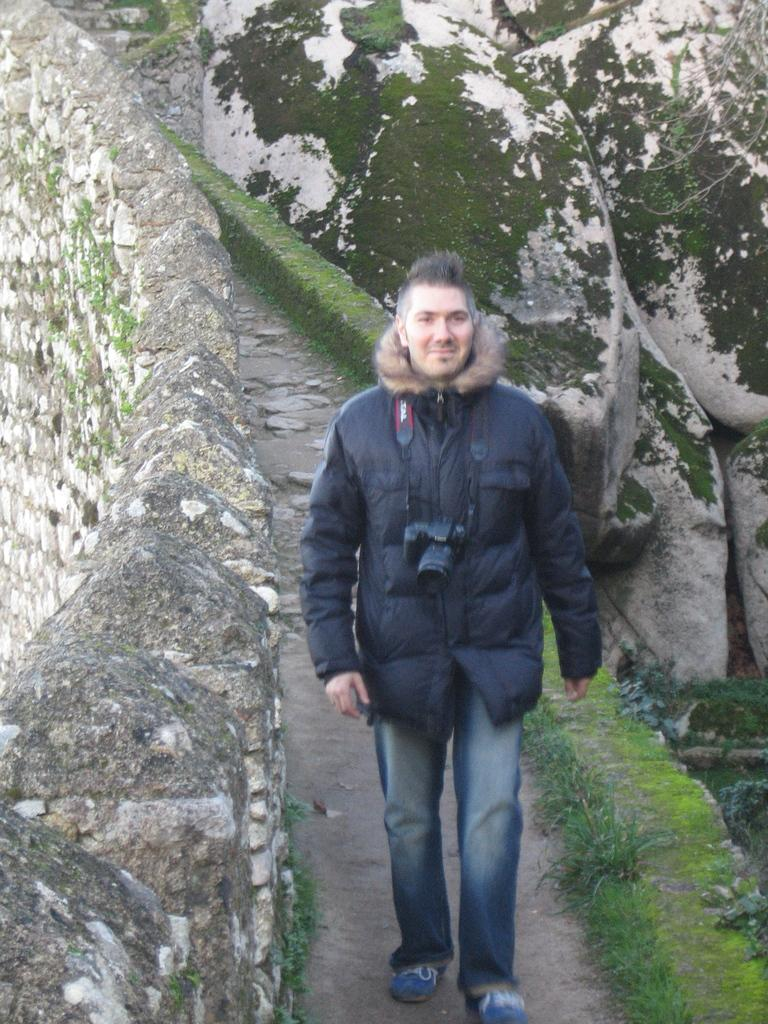Who or what is in the image? There is a person in the image. What type of natural environment is visible in the image? There is grass in the image. What can be seen in the background of the image? There is a wall and rocks in the background of the image. What type of mist can be seen surrounding the person in the image? There is no mist present in the image; it is a clear scene with a person, grass, and a wall in the background. 